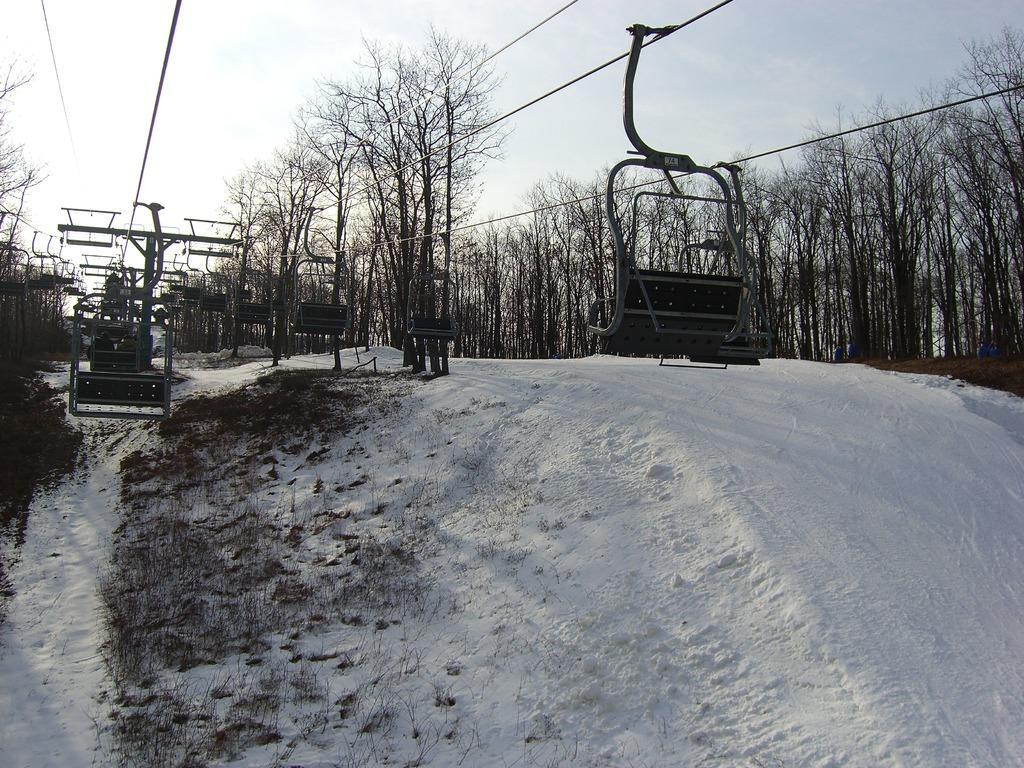What type of vegetation can be seen in the image? There are trees in the image. What is the ground covered with in the image? There is snow and grass visible in the image. What type of transportation can be seen in the image? Ropeways are present in the image. What is visible in the background of the image? The sky is visible in the image. What is the purpose of the jeans in the image? There are no jeans present in the image. What does the regret feel like in the image? There is no mention of regret in the image. 